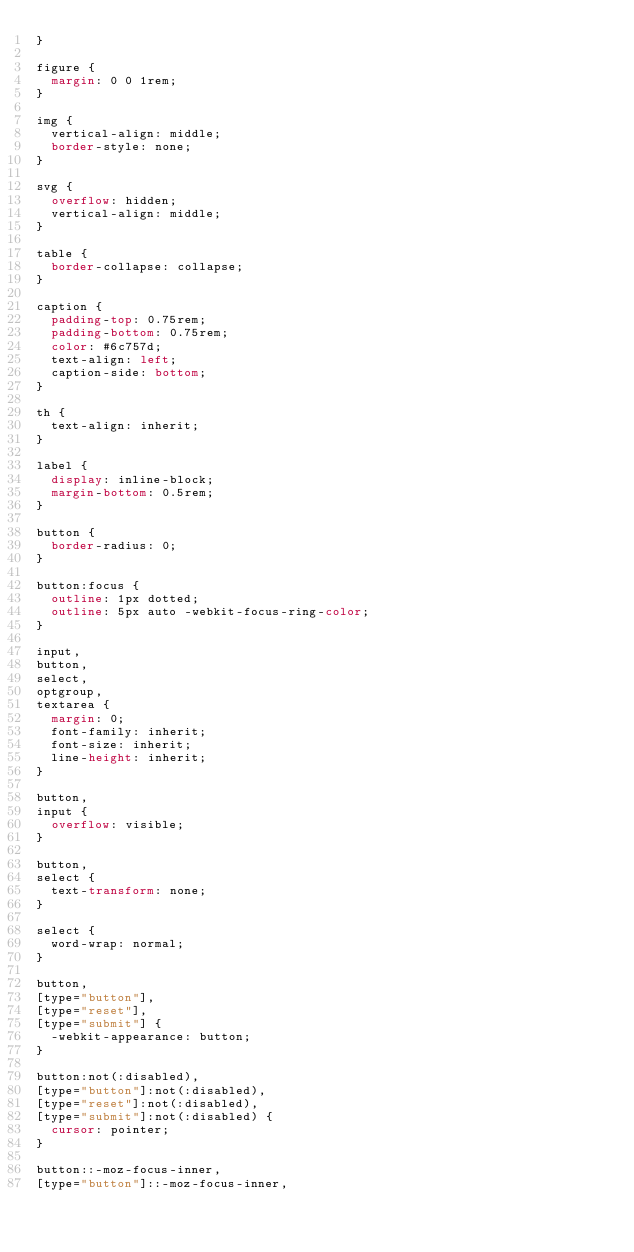Convert code to text. <code><loc_0><loc_0><loc_500><loc_500><_CSS_>}

figure {
  margin: 0 0 1rem;
}

img {
  vertical-align: middle;
  border-style: none;
}

svg {
  overflow: hidden;
  vertical-align: middle;
}

table {
  border-collapse: collapse;
}

caption {
  padding-top: 0.75rem;
  padding-bottom: 0.75rem;
  color: #6c757d;
  text-align: left;
  caption-side: bottom;
}

th {
  text-align: inherit;
}

label {
  display: inline-block;
  margin-bottom: 0.5rem;
}

button {
  border-radius: 0;
}

button:focus {
  outline: 1px dotted;
  outline: 5px auto -webkit-focus-ring-color;
}

input,
button,
select,
optgroup,
textarea {
  margin: 0;
  font-family: inherit;
  font-size: inherit;
  line-height: inherit;
}

button,
input {
  overflow: visible;
}

button,
select {
  text-transform: none;
}

select {
  word-wrap: normal;
}

button,
[type="button"],
[type="reset"],
[type="submit"] {
  -webkit-appearance: button;
}

button:not(:disabled),
[type="button"]:not(:disabled),
[type="reset"]:not(:disabled),
[type="submit"]:not(:disabled) {
  cursor: pointer;
}

button::-moz-focus-inner,
[type="button"]::-moz-focus-inner,</code> 